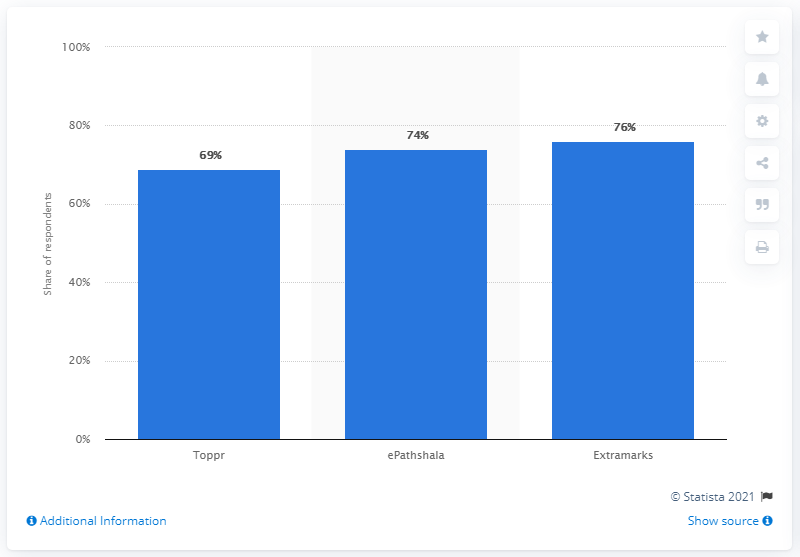Give some essential details in this illustration. According to the survey, 76% of respondents reported that they had increased their use of the educational app, Extramarks. 